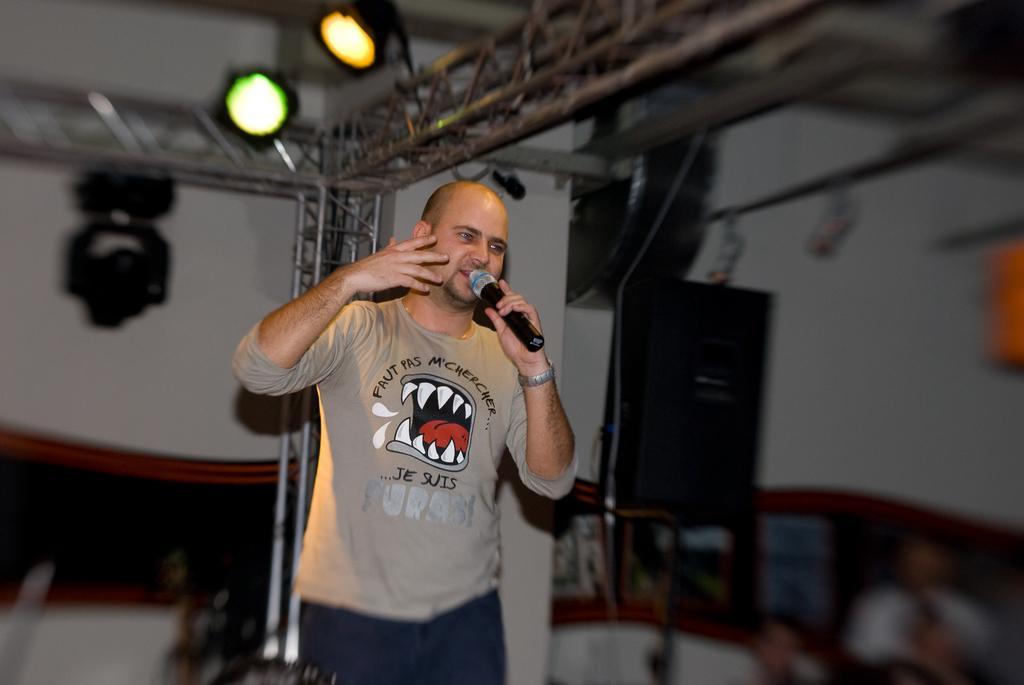In one or two sentences, can you explain what this image depicts? In this image I can see a person standing and holding a microphone. There are lights at the top and the background is blurred. 